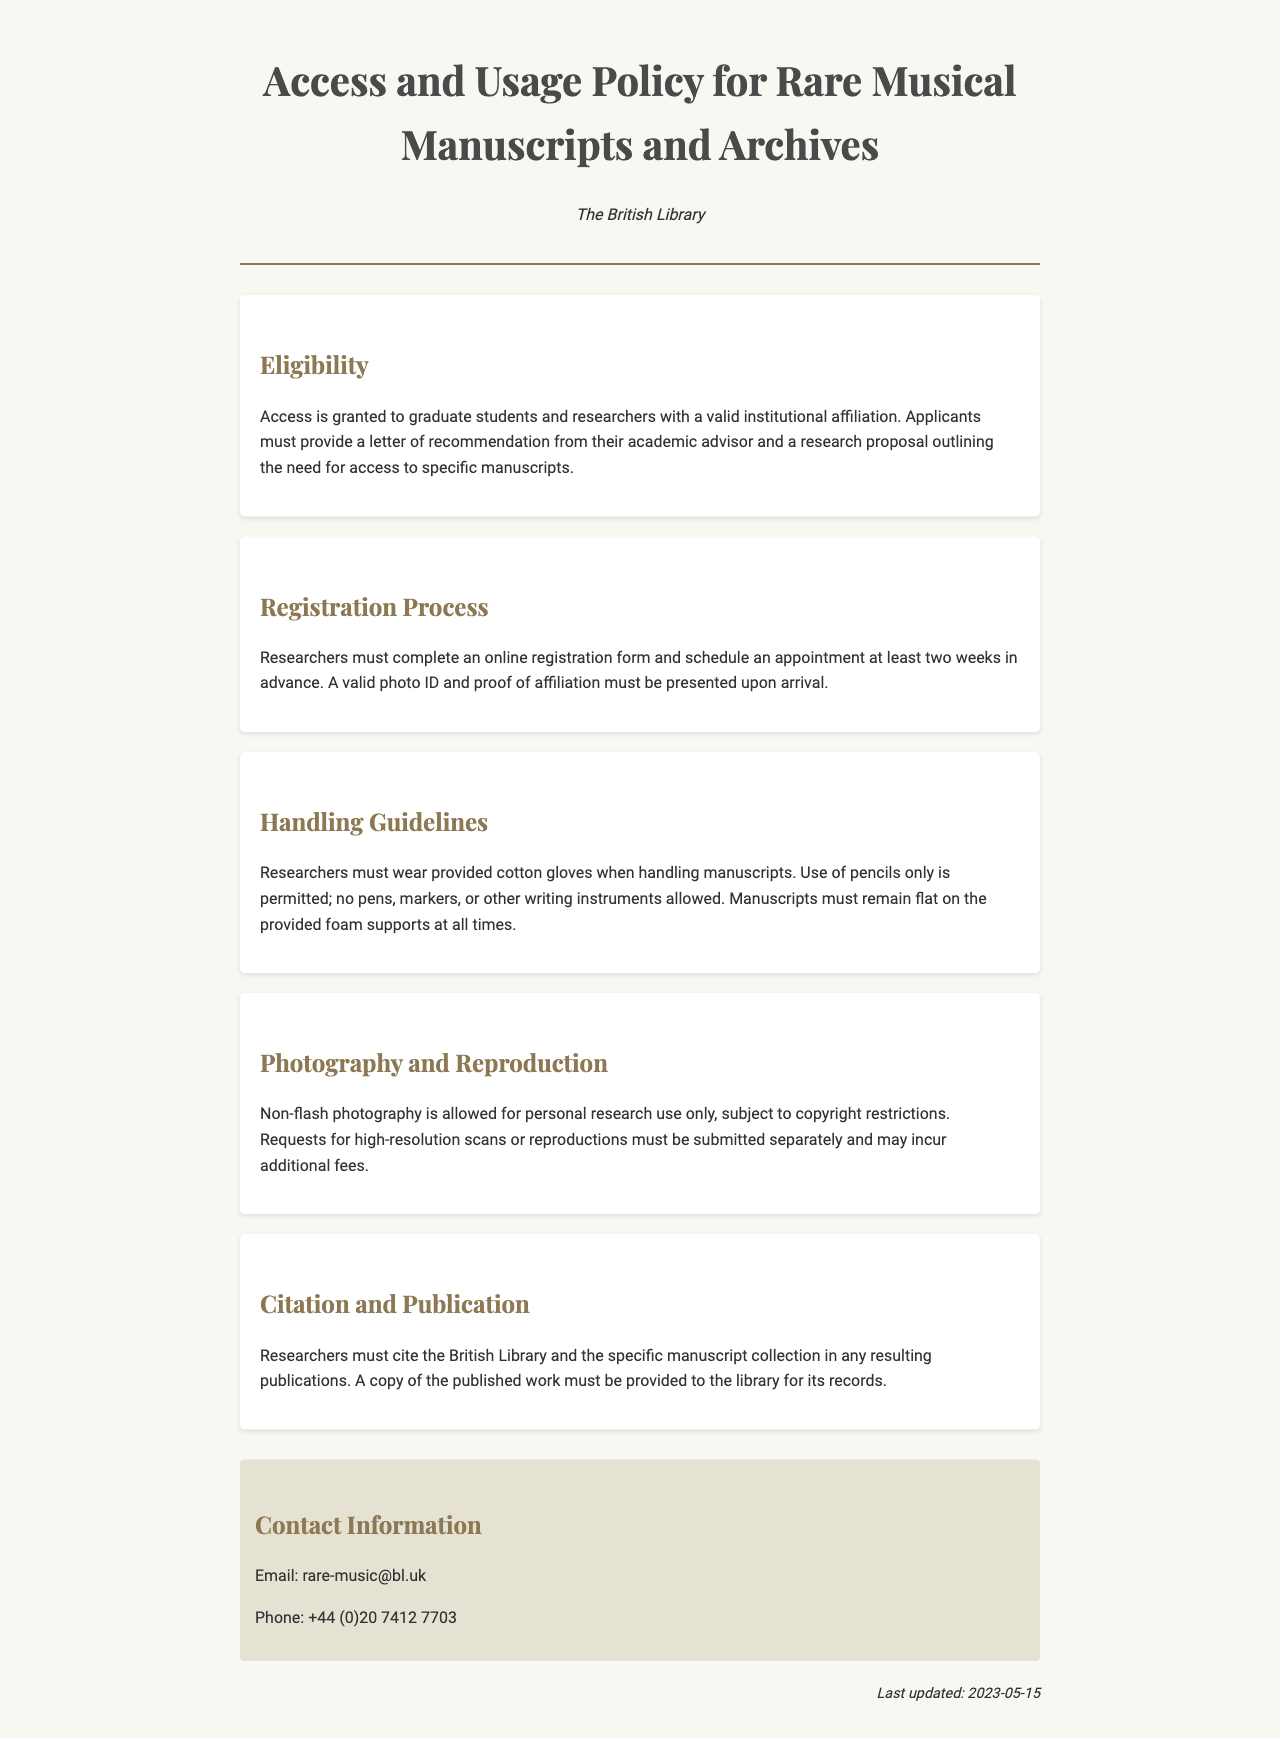What is the eligibility requirement for access? The eligibility requirement states that access is granted to graduate students and researchers with a valid institutional affiliation.
Answer: Graduate students and researchers with a valid institutional affiliation How many weeks in advance must appointments be scheduled? The document specifies that researchers must schedule an appointment at least two weeks in advance.
Answer: Two weeks What item must researchers wear when handling manuscripts? The handling guidelines require researchers to wear provided cotton gloves when handling manuscripts.
Answer: Cotton gloves What type of photography is allowed for personal research use? The document states that non-flash photography is allowed for personal research use only.
Answer: Non-flash photography What must be provided to the library after publication? The citation and publication section states that a copy of the published work must be provided to the library for its records.
Answer: A copy of the published work 